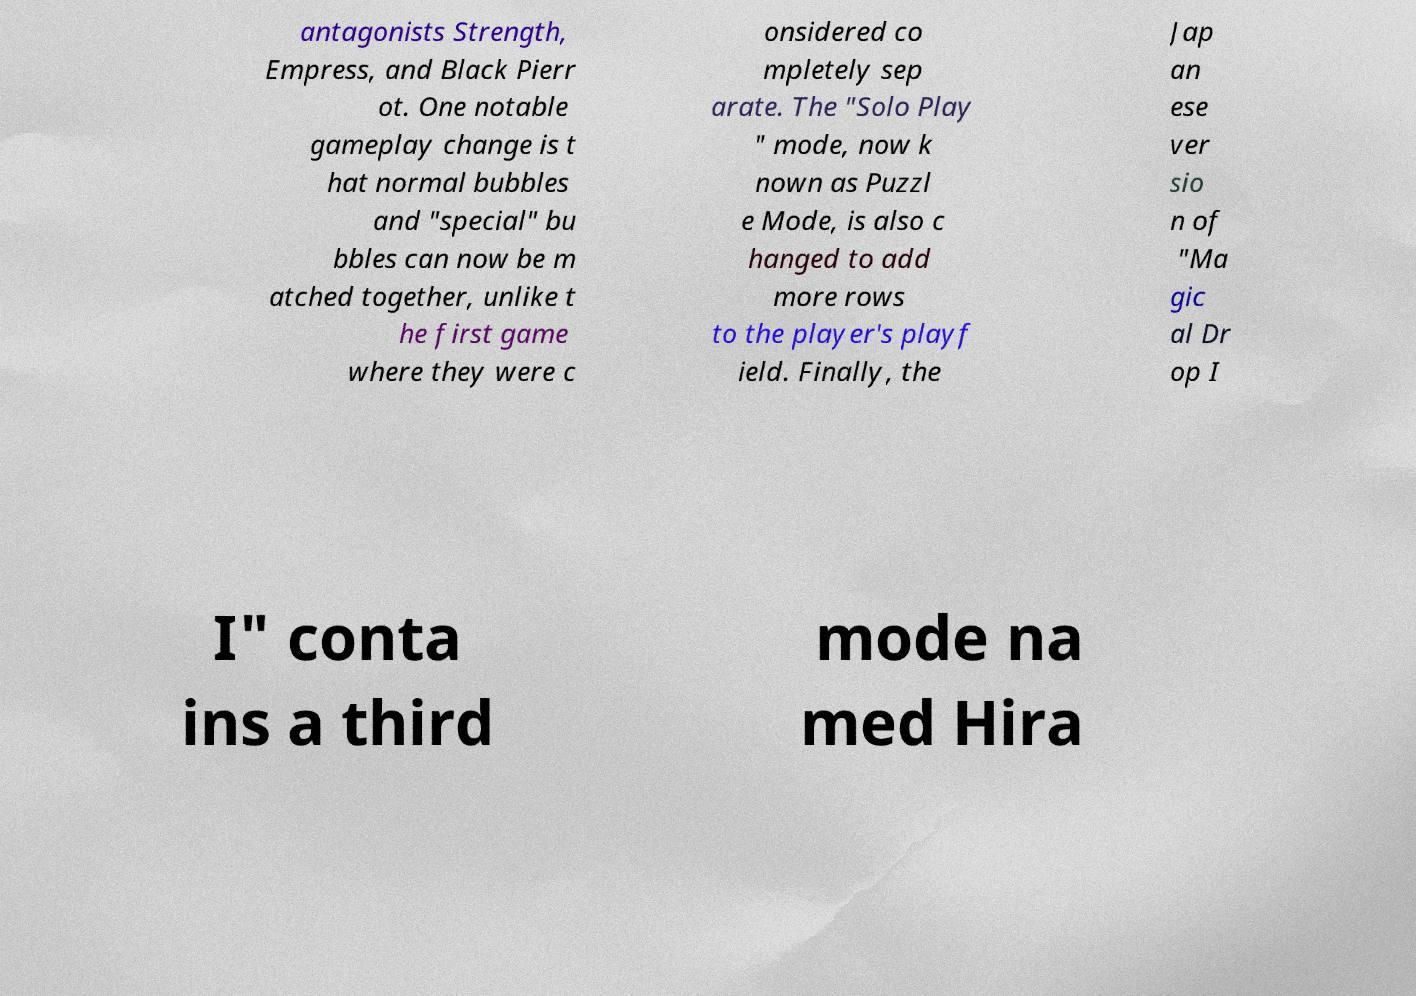Please read and relay the text visible in this image. What does it say? antagonists Strength, Empress, and Black Pierr ot. One notable gameplay change is t hat normal bubbles and "special" bu bbles can now be m atched together, unlike t he first game where they were c onsidered co mpletely sep arate. The "Solo Play " mode, now k nown as Puzzl e Mode, is also c hanged to add more rows to the player's playf ield. Finally, the Jap an ese ver sio n of "Ma gic al Dr op I I" conta ins a third mode na med Hira 